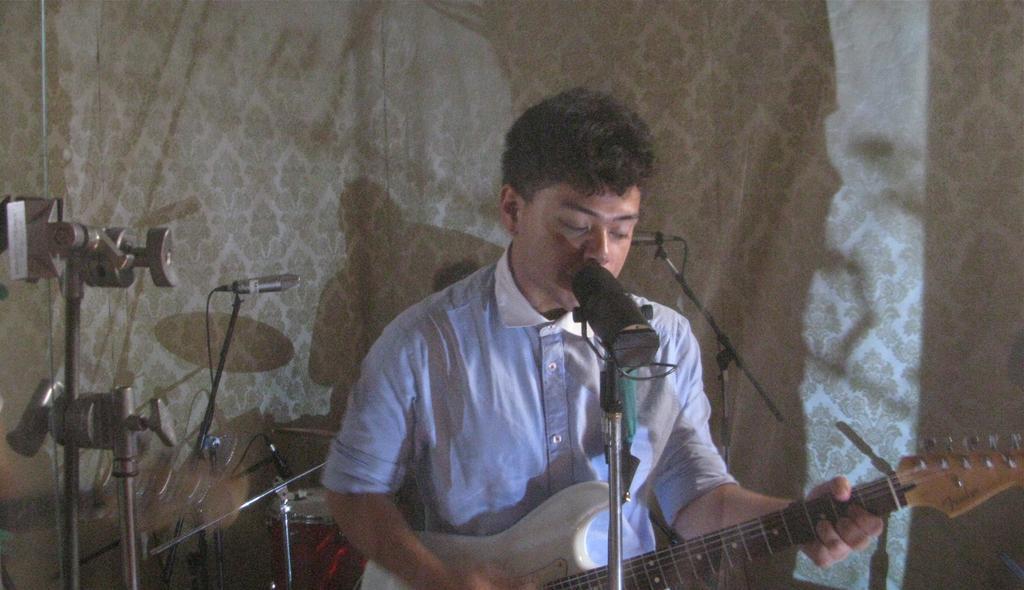Please provide a concise description of this image. In this image there is a man sitting and playing a guitar and singing a song in the microphone , and at the background there are microphone , drums, wall. 